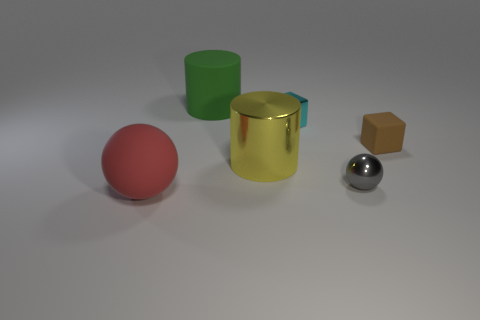Add 1 big blue metallic things. How many objects exist? 7 Subtract all cylinders. How many objects are left? 4 Subtract 1 green cylinders. How many objects are left? 5 Subtract all red blocks. Subtract all large red rubber things. How many objects are left? 5 Add 1 cyan metal objects. How many cyan metal objects are left? 2 Add 1 purple rubber balls. How many purple rubber balls exist? 1 